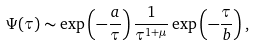Convert formula to latex. <formula><loc_0><loc_0><loc_500><loc_500>\Psi ( \tau ) \sim \exp \left ( - \frac { a } { \tau } \right ) \frac { 1 } { \tau ^ { 1 + \mu } } \exp \left ( - \frac { \tau } { b } \right ) ,</formula> 